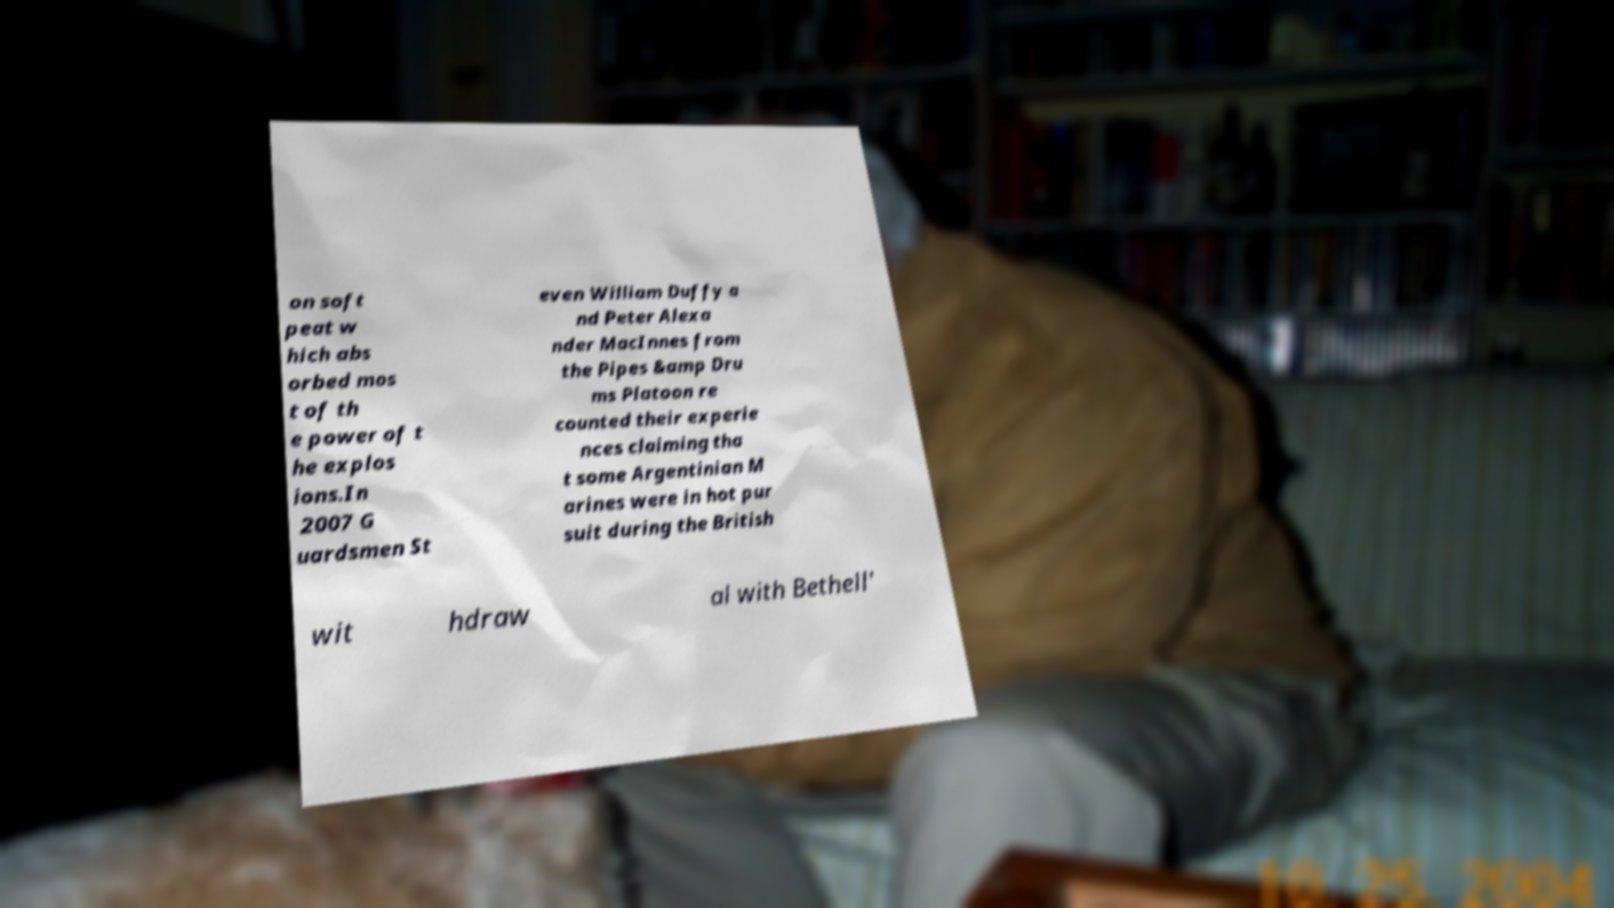Could you extract and type out the text from this image? on soft peat w hich abs orbed mos t of th e power of t he explos ions.In 2007 G uardsmen St even William Duffy a nd Peter Alexa nder MacInnes from the Pipes &amp Dru ms Platoon re counted their experie nces claiming tha t some Argentinian M arines were in hot pur suit during the British wit hdraw al with Bethell' 